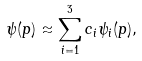Convert formula to latex. <formula><loc_0><loc_0><loc_500><loc_500>\psi ( p ) \approx \sum _ { i = 1 } ^ { 3 } c _ { i } \psi _ { i } ( p ) ,</formula> 